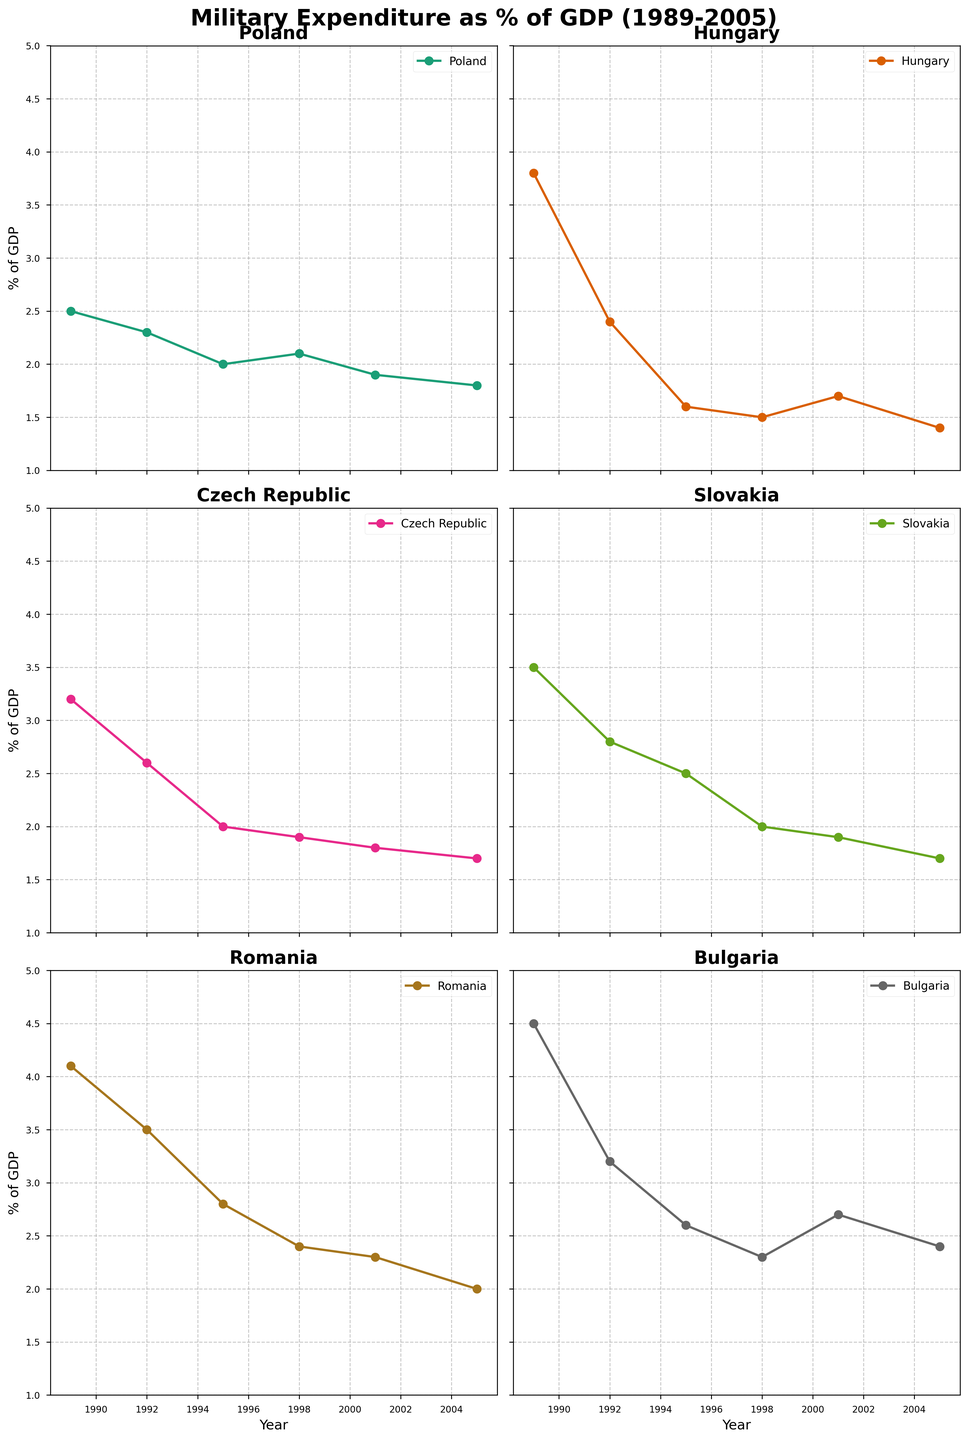What is the title of the figure? The title of the figure is displayed at the top. It reads "Military Expenditure as % of GDP (1989-2005)" in bold and large font.
Answer: Military Expenditure as % of GDP (1989-2005) Which country had the highest military expenditure as a percentage of GDP in 1989? From the data in the subplot for each country in 1989, Bulgaria's military expenditure as a percentage of GDP was the highest at 4.5%.
Answer: Bulgaria How did Poland's military expenditure as a percentage of GDP change from 1989 to 2005? Looking at the Poland subplot, the military expenditure decreased from 2.5% in 1989 to 1.8% in 2005.
Answer: It decreased Which country had the most significant decrease in military expenditure as a percentage of GDP from 1989 to 2005? By comparing all the subplots, Hungary's military expenditure decreased from 3.8% in 1989 to 1.4% in 2005, which is the most significant decrease.
Answer: Hungary Between which years did Romania's military expenditure as a percentage of GDP experience the largest drop? Looking at the Romania subplot, the largest drop appears between 1989 (4.1%) and 1992 (3.5%).
Answer: 1989 to 1992 How does the trend of military expenditure as a percentage of GDP for Slovakia compare to that of the Czech Republic? Both Slovakia and the Czech Republic show a decreasing trend in their military expenditure as a percentage of GDP from 1989 to 2005, but Slovakia starts slightly higher in 1989 and also ends slightly higher in 2005.
Answer: Both decrease, Slovakia starts and ends slightly higher In what year did Hungary have the sharpest decline in military expenditure as a percentage of GDP? The Hungary subplot shows that the sharpest decline happened between 1989 (3.8%) and 1992 (2.4%).
Answer: Between 1989 and 1992 What is the average military expenditure as a percentage of GDP for Bulgaria from 1989 to 2005? To find the average, add Bulgaria's values for the given years and divide by the number of years. (4.5 + 3.2 + 2.6 + 2.3 + 2.7 + 2.4) / 6 = 18.7 / 6 = 3.12
Answer: 3.12% Which country had the least decline in military expenditure as a percentage of GDP from 1989 to 2005? By comparing the starting and ending values for each country, Poland had the least decline, from 2.5% to 1.8%, a decline of 0.7%.
Answer: Poland How many countries had military expenditure as a percentage of GDP below 2% in 2005? By examining the values in 2005 across all subplots, Hungary (1.4%), Czech Republic (1.7%), and Slovakia (1.7%) had military expenditure below 2%.
Answer: Three countries 